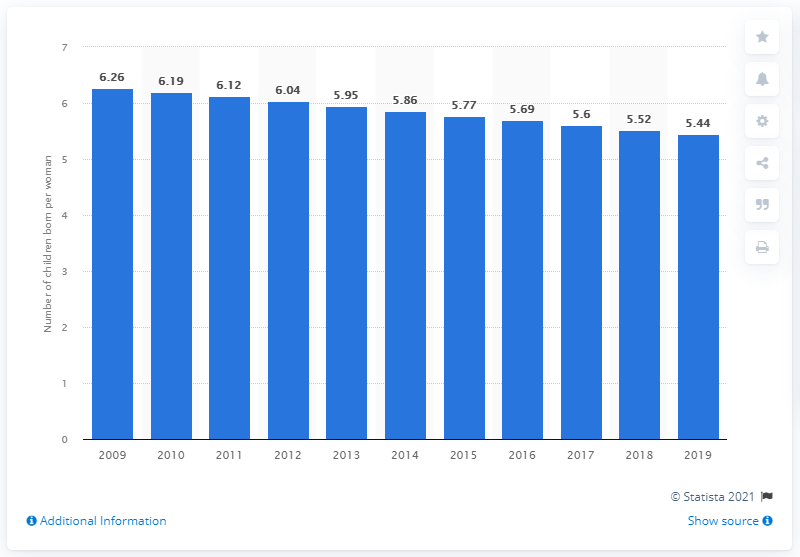Outline some significant characteristics in this image. The fertility rate in Angola in 2019 was 5.44, according to recent data. 